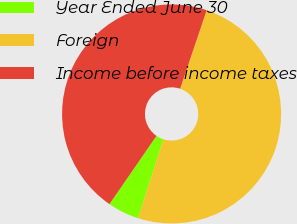Convert chart to OTSL. <chart><loc_0><loc_0><loc_500><loc_500><pie_chart><fcel>Year Ended June 30<fcel>Foreign<fcel>Income before income taxes<nl><fcel>4.65%<fcel>49.76%<fcel>45.59%<nl></chart> 